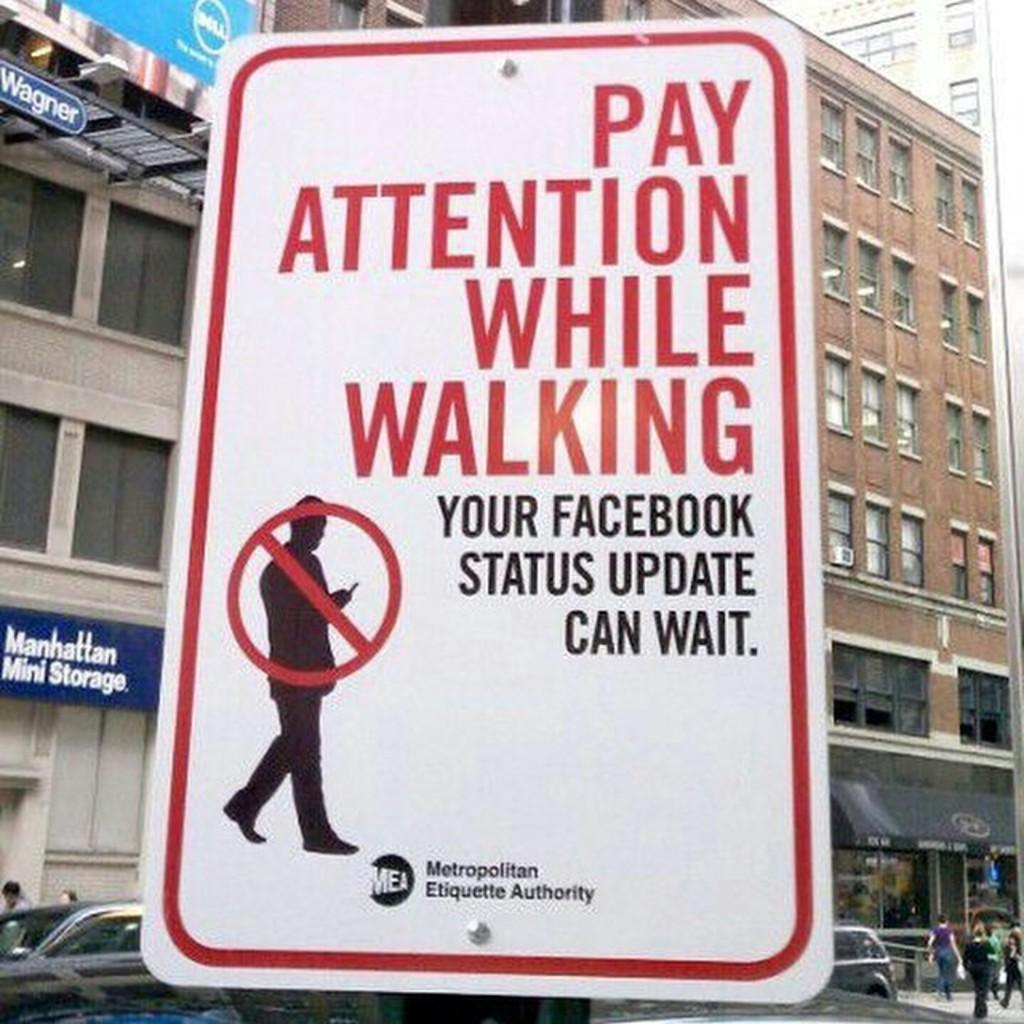<image>
Create a compact narrative representing the image presented. A white sign that says Pay Attention While walking in red 